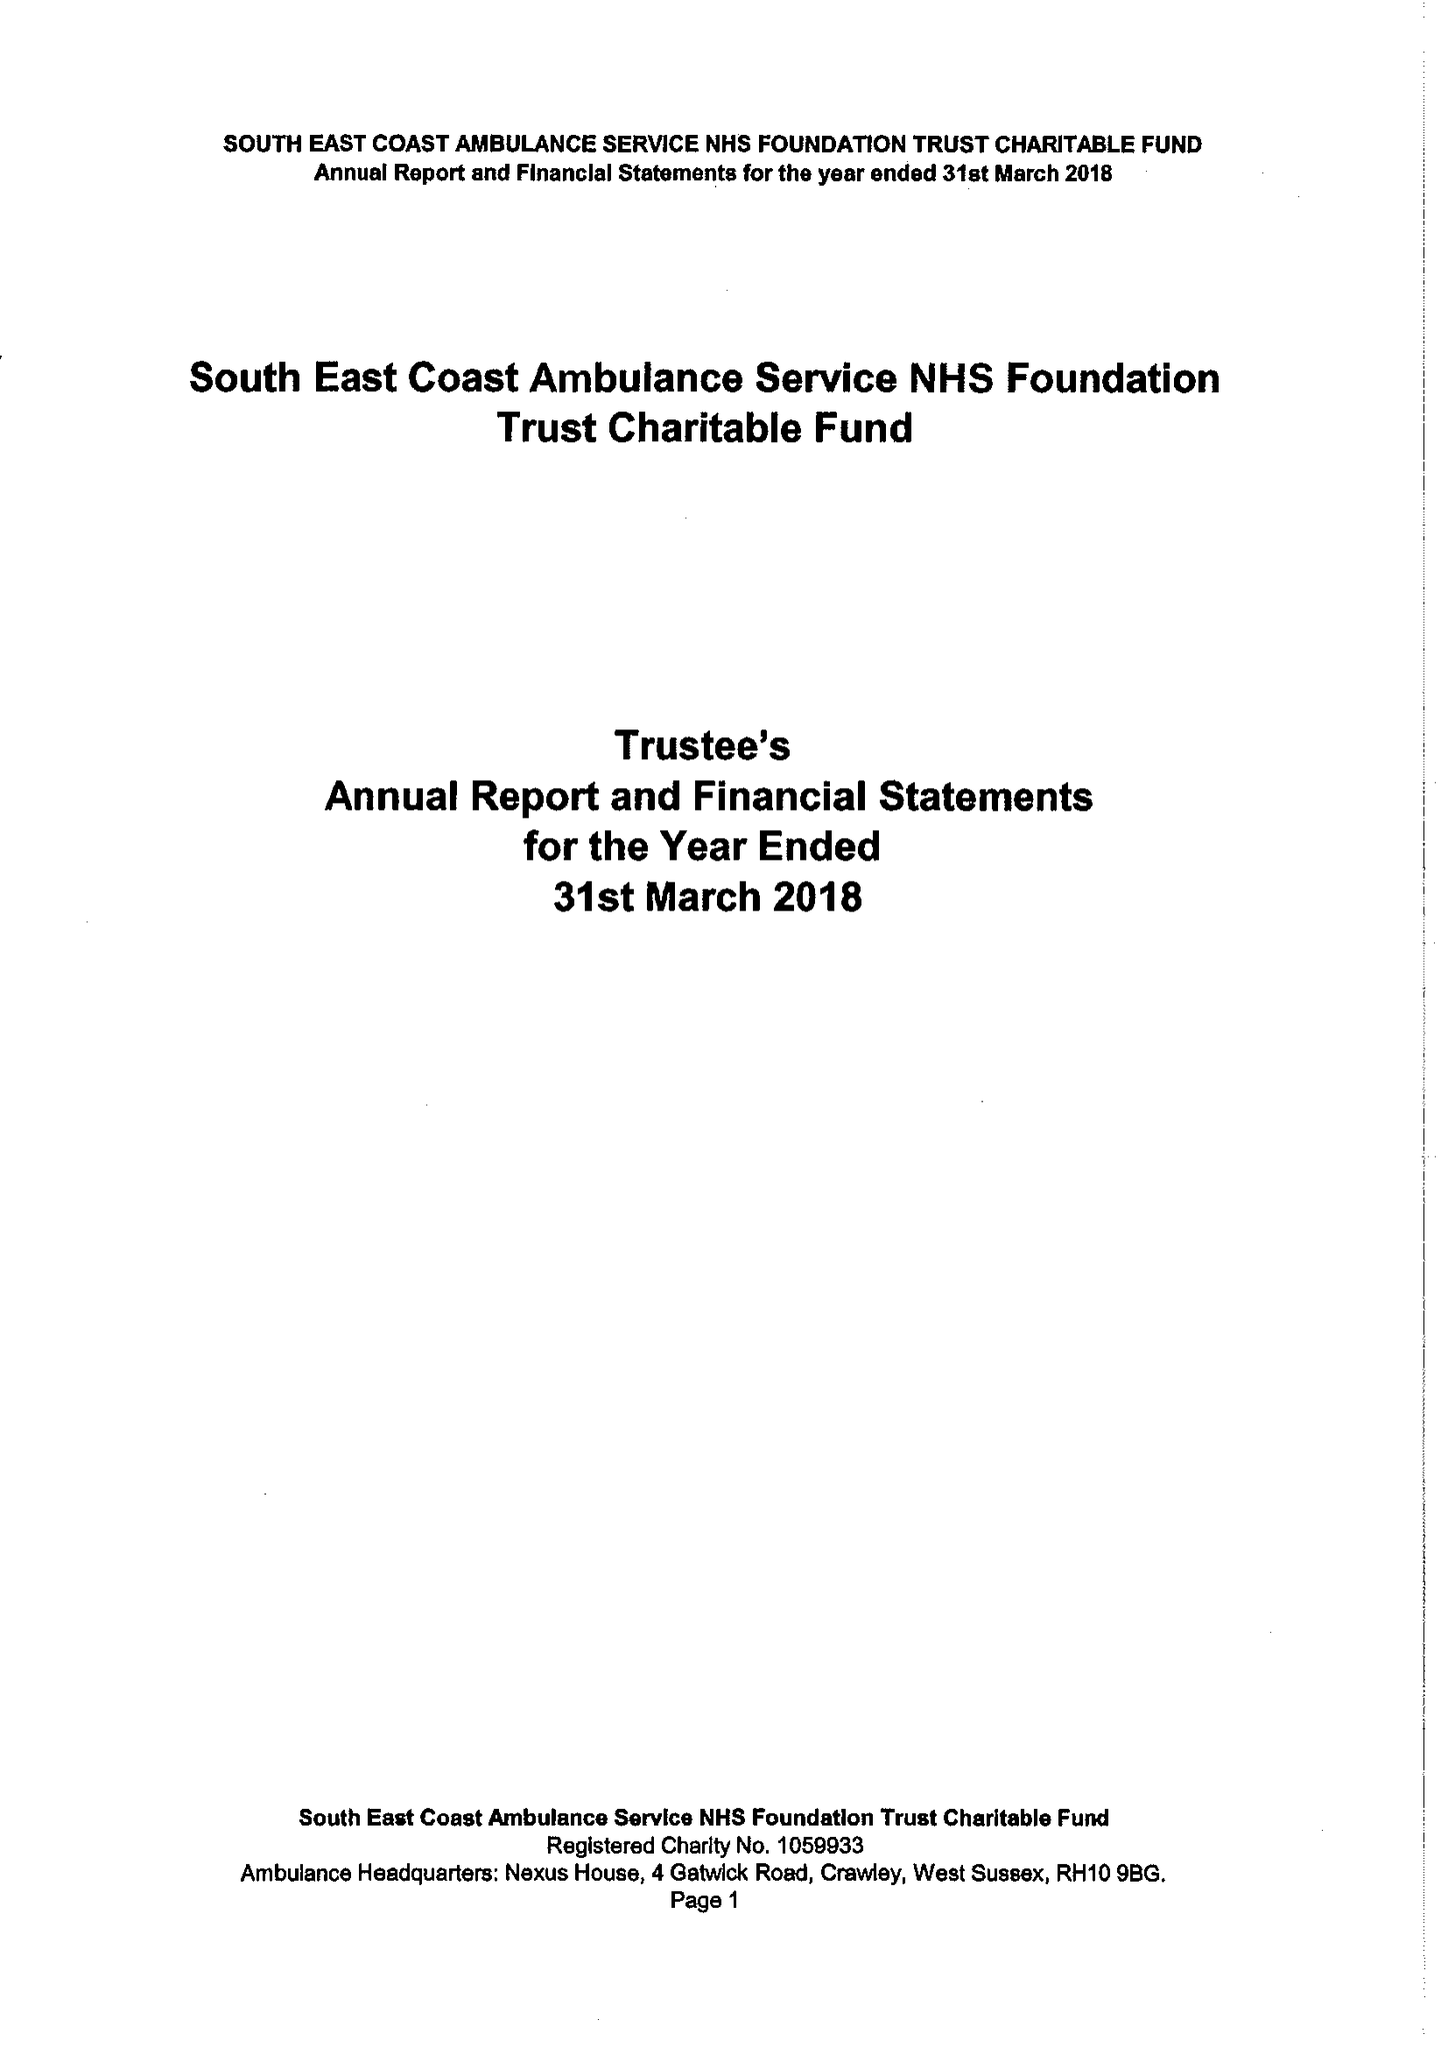What is the value for the address__postcode?
Answer the question using a single word or phrase. RH10 9BG 